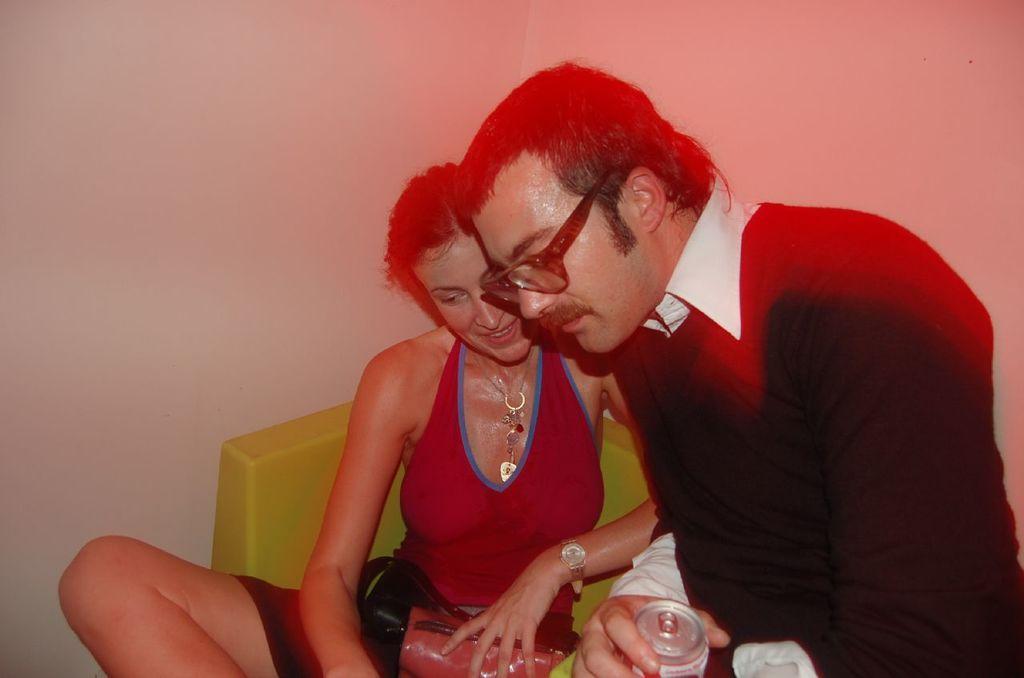In one or two sentences, can you explain what this image depicts? In this picture we can see a woman is sitting on a chair and a man is holding a tin. Behind the two persons, there is a wall. 